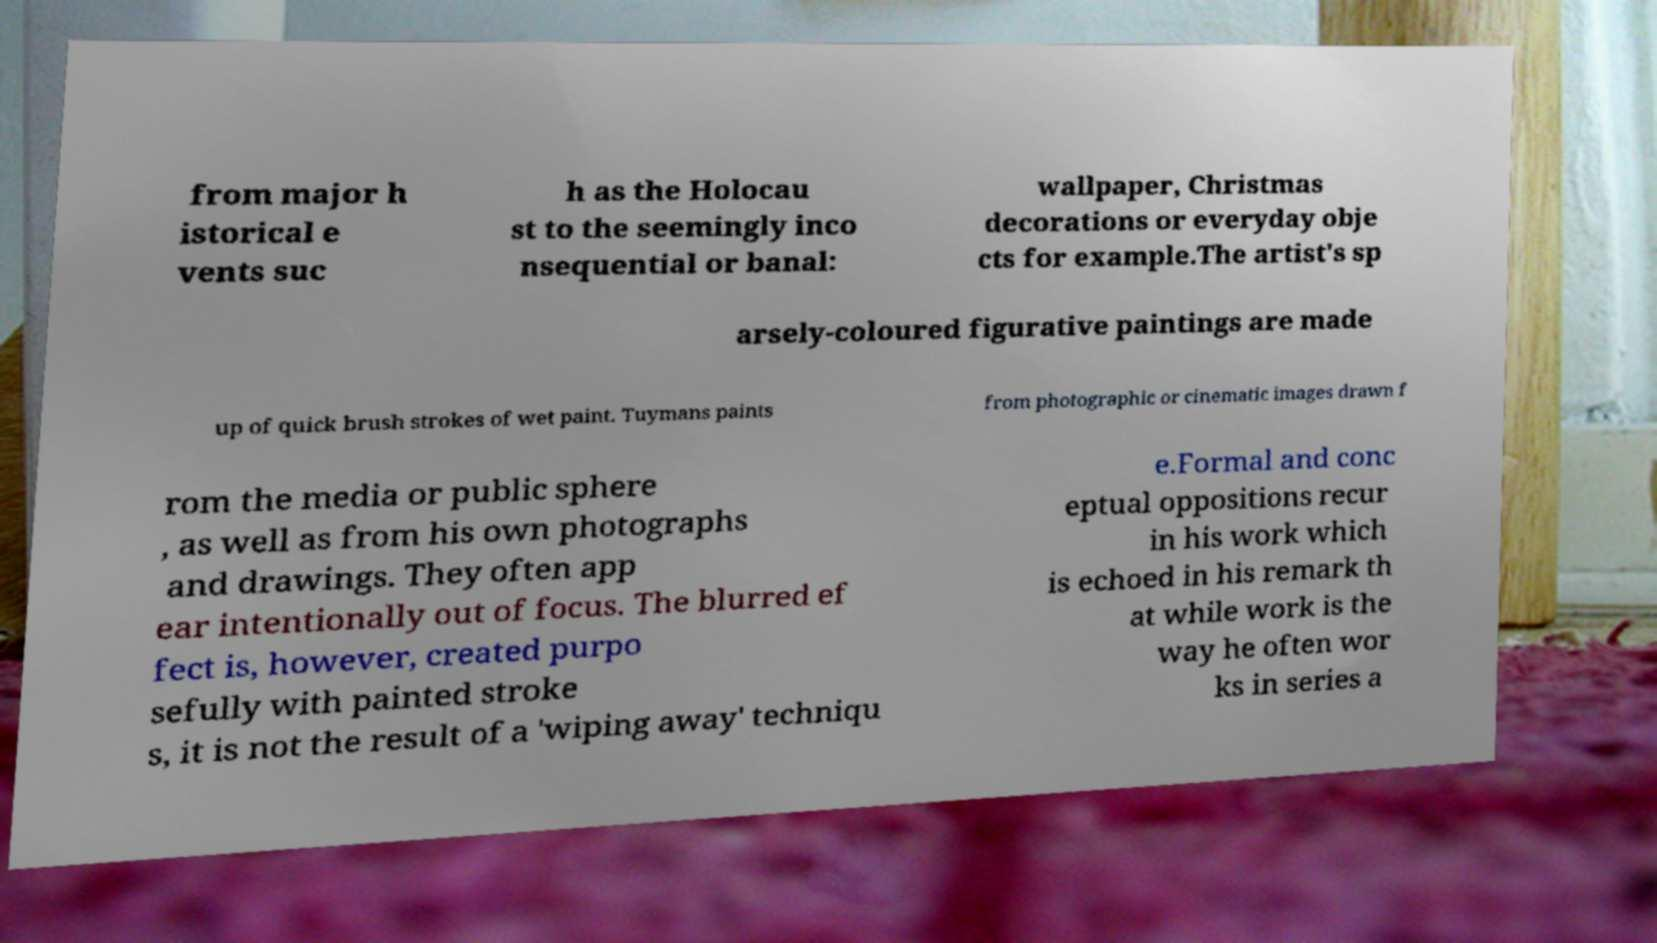For documentation purposes, I need the text within this image transcribed. Could you provide that? from major h istorical e vents suc h as the Holocau st to the seemingly inco nsequential or banal: wallpaper, Christmas decorations or everyday obje cts for example.The artist's sp arsely-coloured figurative paintings are made up of quick brush strokes of wet paint. Tuymans paints from photographic or cinematic images drawn f rom the media or public sphere , as well as from his own photographs and drawings. They often app ear intentionally out of focus. The blurred ef fect is, however, created purpo sefully with painted stroke s, it is not the result of a 'wiping away' techniqu e.Formal and conc eptual oppositions recur in his work which is echoed in his remark th at while work is the way he often wor ks in series a 